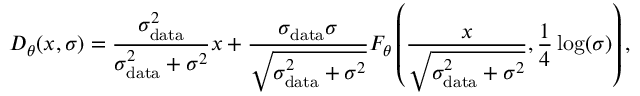<formula> <loc_0><loc_0><loc_500><loc_500>D _ { \theta } ( x , \sigma ) = \frac { \sigma _ { d a t a } ^ { 2 } } { \sigma _ { d a t a } ^ { 2 } + \sigma ^ { 2 } } x + \frac { \sigma _ { d a t a } \sigma } { \sqrt { \sigma _ { d a t a } ^ { 2 } + \sigma ^ { 2 } } } F _ { \theta } \left ( \frac { x } { \sqrt { \sigma _ { d a t a } ^ { 2 } + \sigma ^ { 2 } } } , \frac { 1 } { 4 } \log ( \sigma ) \right ) ,</formula> 